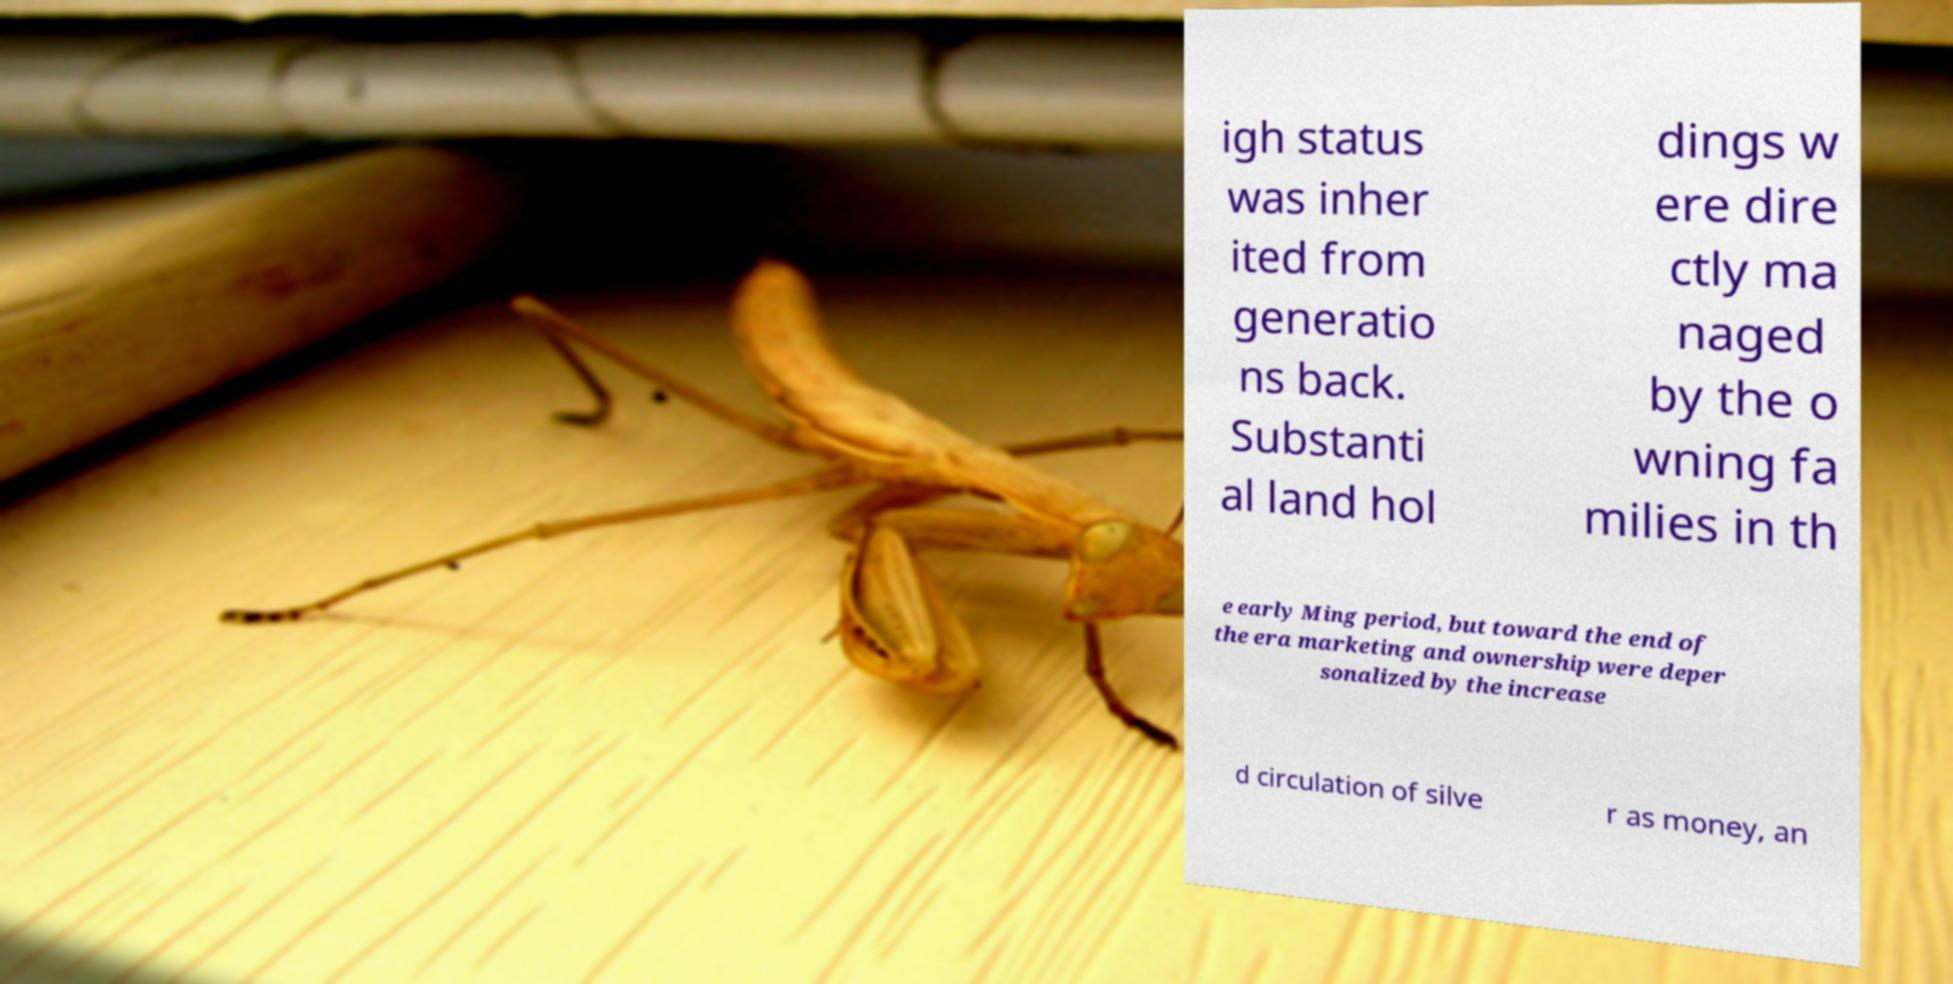There's text embedded in this image that I need extracted. Can you transcribe it verbatim? igh status was inher ited from generatio ns back. Substanti al land hol dings w ere dire ctly ma naged by the o wning fa milies in th e early Ming period, but toward the end of the era marketing and ownership were deper sonalized by the increase d circulation of silve r as money, an 